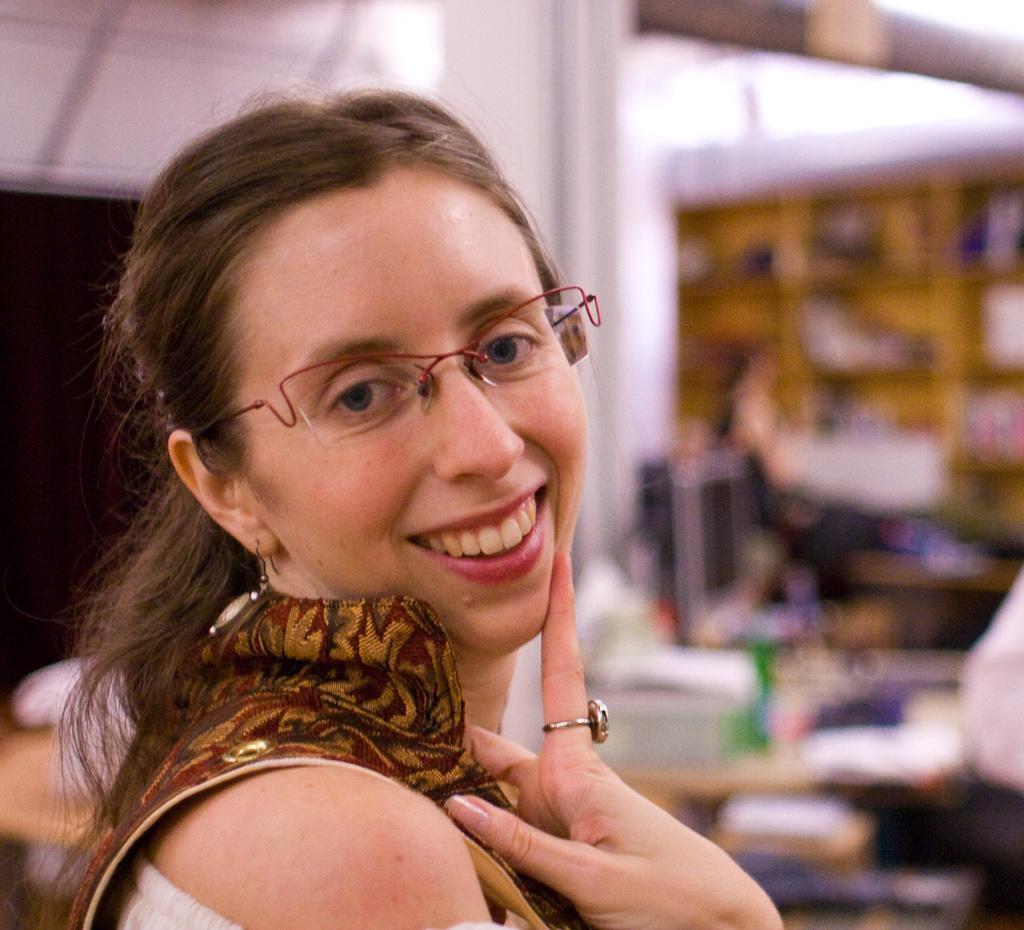Describe this image in one or two sentences. In the center of the image there is a lady. The background of the image is blurry. 